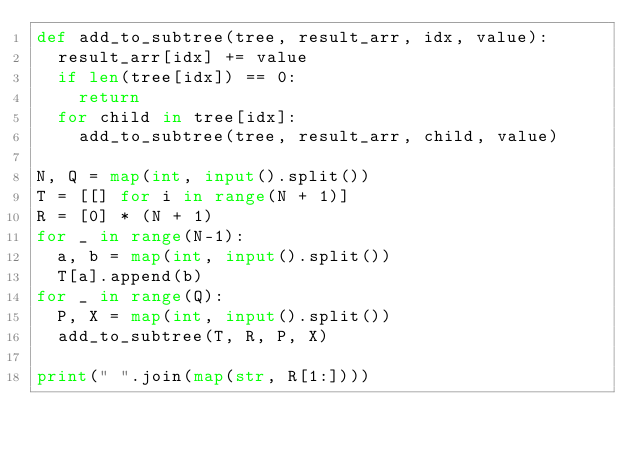<code> <loc_0><loc_0><loc_500><loc_500><_Python_>def add_to_subtree(tree, result_arr, idx, value):
  result_arr[idx] += value
  if len(tree[idx]) == 0:
    return
  for child in tree[idx]:
    add_to_subtree(tree, result_arr, child, value)

N, Q = map(int, input().split())
T = [[] for i in range(N + 1)]
R = [0] * (N + 1)
for _ in range(N-1):
  a, b = map(int, input().split())
  T[a].append(b)
for _ in range(Q):
  P, X = map(int, input().split())
  add_to_subtree(T, R, P, X)

print(" ".join(map(str, R[1:])))
</code> 